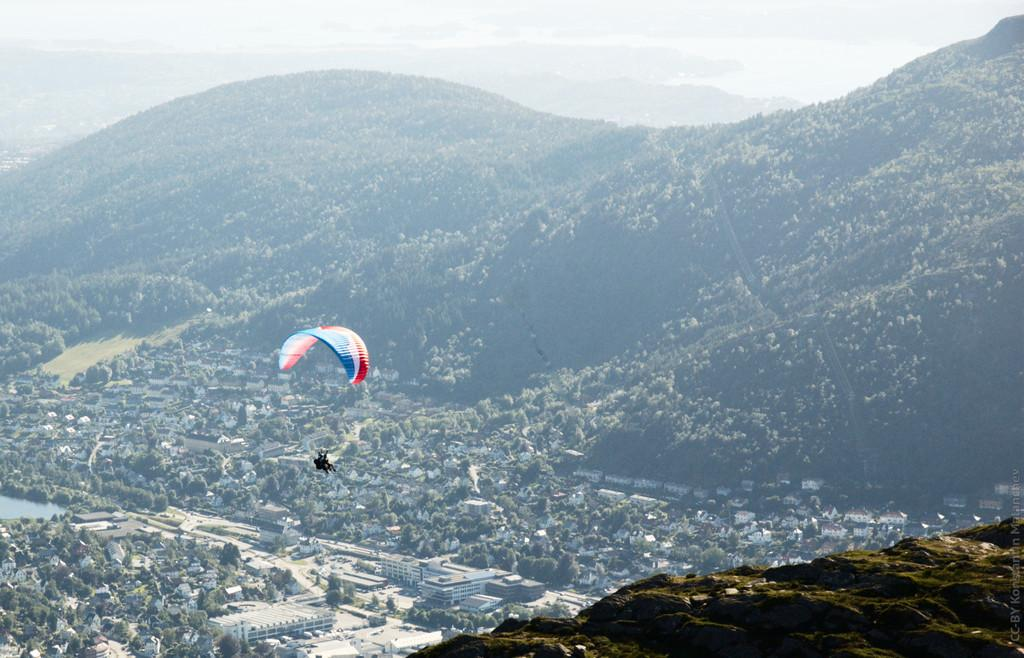What is the person in the image doing? The person is flying using a parachute. What can be seen in the background of the image? There are hills, buildings, water, trees, mountains, and the sky visible in the background of the image. How does the organization help the person increase their plate size in the image? There is no organization or plate present in the image; it features a person flying with a parachute in a landscape with hills, buildings, water, trees, mountains, and the sky. 